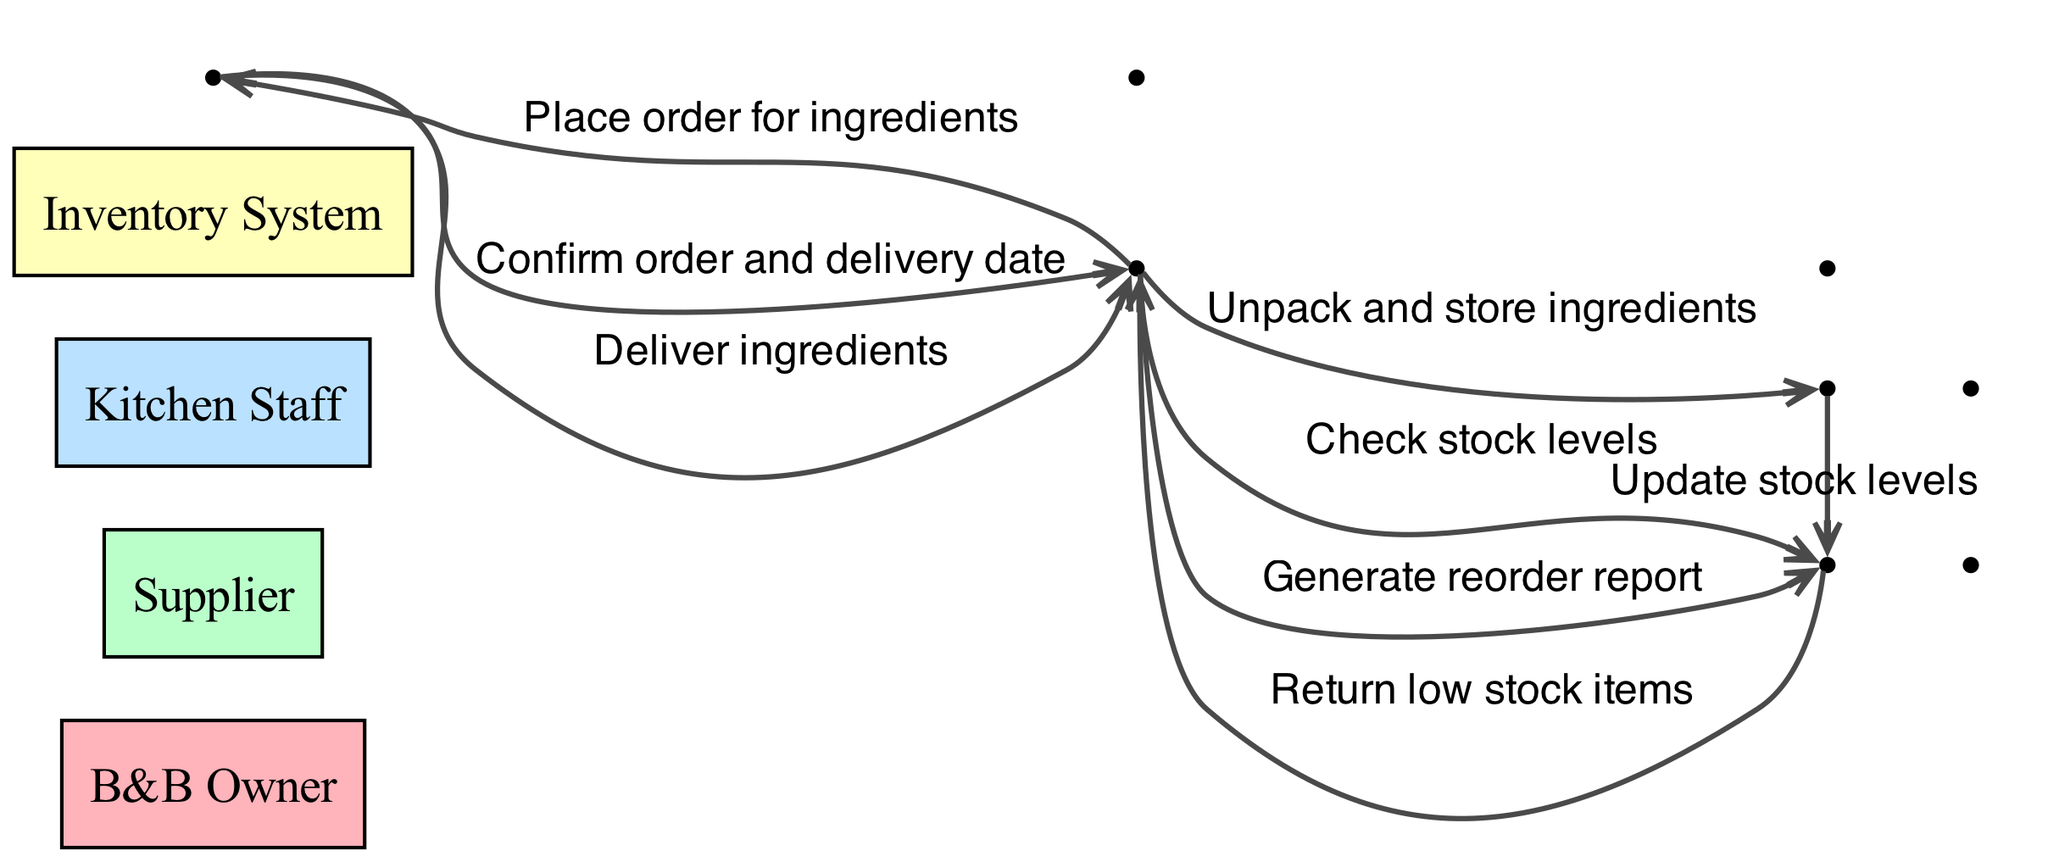What is the first action taken in the process? The first action in the process, as shown in the diagram, involves the B&B Owner checking stock levels with the Inventory System.
Answer: Check stock levels How many actors are involved in the diagram? There are four actors mentioned in the diagram: B&B Owner, Supplier, Kitchen Staff, and Inventory System.
Answer: Four Which actor confirms the order and delivery date? The Supplier is responsible for confirming the order and delivery date to the B&B Owner after the order is placed.
Answer: Supplier What action occurs after the ingredients are delivered? Following the delivery of ingredients, the B&B Owner instructs the Kitchen Staff to unpack and store the ingredients.
Answer: Unpack and store ingredients What does the Kitchen Staff do after receiving the ingredients? After unpacking and storing the ingredients, the Kitchen Staff updates the stock levels in the Inventory System.
Answer: Update stock levels What action does the B&B Owner take at the end of the process? At the end of the process, the B&B Owner generates a reorder report using the Inventory System.
Answer: Generate reorder report Which action takes place directly after checking stock levels? The action that takes place directly after checking stock levels is the return of low stock items from the Inventory System to the B&B Owner.
Answer: Return low stock items How many distinct messages are exchanged between the B&B Owner and the Supplier? There are two distinct messages exchanged between the B&B Owner and the Supplier: placing the order and confirming the order and delivery date.
Answer: Two Which actor interacts with the Inventory System the most? The B&B Owner interacts with the Inventory System multiple times throughout the process: to check stock levels, to generate reorder reports, and to receive low stock items.
Answer: B&B Owner 